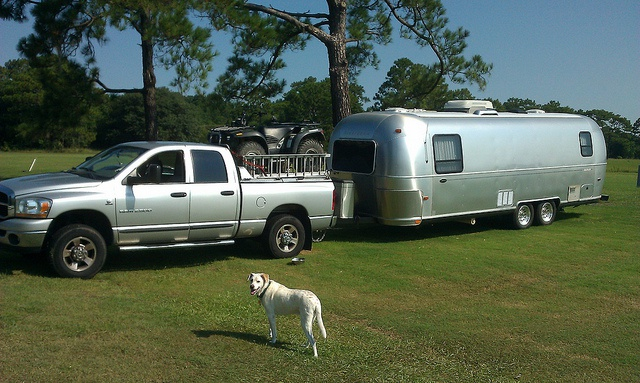Describe the objects in this image and their specific colors. I can see truck in black, white, gray, and darkgray tones, truck in black, gray, darkgray, and darkgreen tones, and dog in black, gray, beige, darkgray, and darkgreen tones in this image. 